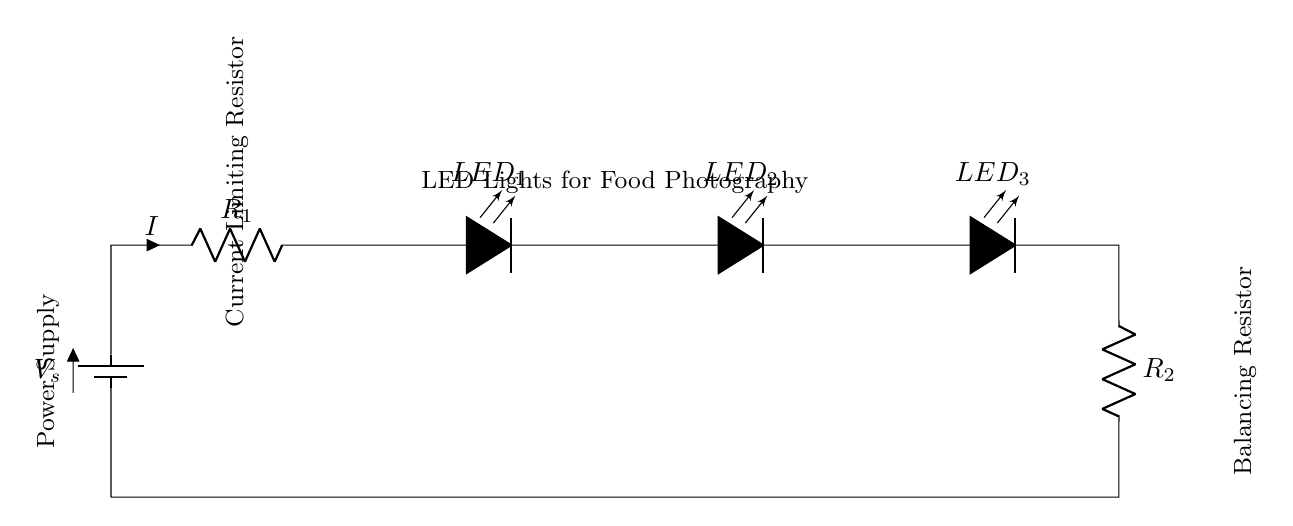What is the total number of LED lights in this circuit? The circuit diagram illustrates three LED lights connected in series for the food photography lighting setup.
Answer: Three What is the role of the resistor labeled R1? Resistor R1 is labeled as a current-limiting resistor, which means its function is to restrict the amount of current flowing through the LED lights to prevent them from burning out.
Answer: Current-limiting What is the purpose of the balancing resistor R2? The balancing resistor R2 is included to ensure the current flowing through the circuit remains stable and to balance the performance across the LEDs, preventing uneven lighting.
Answer: Balancing What is the current direction in this circuit? The current flows from the positive terminal of the battery, through the current limiting resistor R1, then through the LEDs in sequence, and finally through the balancing resistor R2 to return to the battery's negative terminal.
Answer: Clockwise If the supply voltage is 9 volts, what can be the expected forward voltage drop across each LED light if they are the same type? In a series circuit, the total voltage drop is divided among all components. If using standard LEDs, the typical forward voltage drop per LED can be approximately 2 volts (this can vary by type), so with three LEDs, you would expect around 6 volts total drop for three LEDs in series.
Answer: 2 volts How does adding more LED lights affect the total current in this circuit? In a series circuit, adding more LED lights increases the total resistance, which reduces the overall current according to Ohm's law (I = V/R), assuming the supply voltage remains constant.
Answer: Decreases What would happen if one LED fails in this series circuit? If one LED fails (opens), the entire circuit will break, causing all LEDs to turn off, as current cannot flow through an open circuit.
Answer: All turn off 